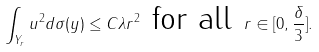<formula> <loc_0><loc_0><loc_500><loc_500>\int _ { Y _ { r } } u ^ { 2 } d \sigma ( y ) \leq C \lambda r ^ { 2 } \text { for all } r \in [ 0 , \frac { \delta } { 3 } ] .</formula> 